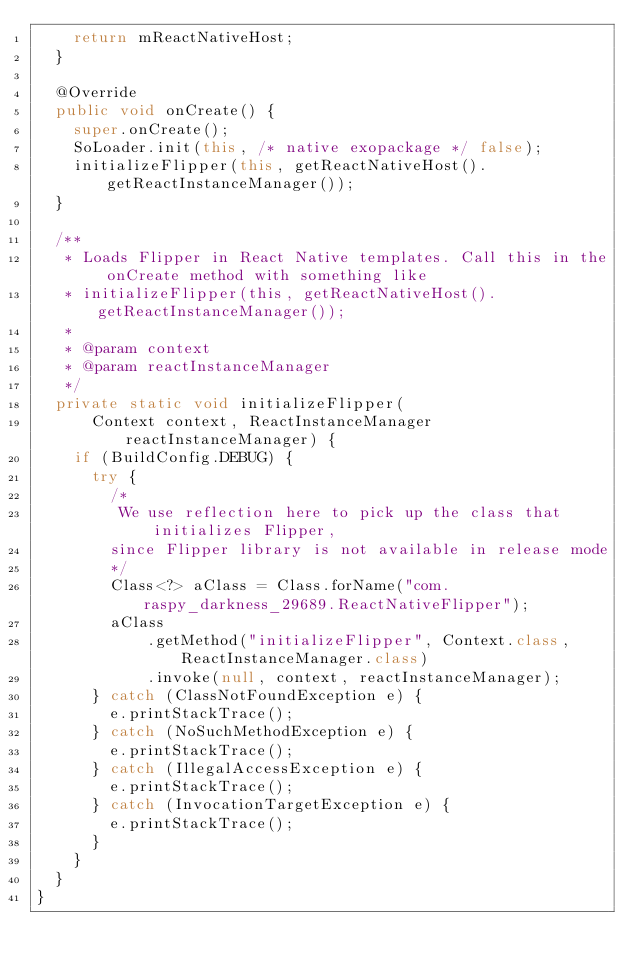<code> <loc_0><loc_0><loc_500><loc_500><_Java_>    return mReactNativeHost;
  }

  @Override
  public void onCreate() {
    super.onCreate();
    SoLoader.init(this, /* native exopackage */ false);
    initializeFlipper(this, getReactNativeHost().getReactInstanceManager());
  }

  /**
   * Loads Flipper in React Native templates. Call this in the onCreate method with something like
   * initializeFlipper(this, getReactNativeHost().getReactInstanceManager());
   *
   * @param context
   * @param reactInstanceManager
   */
  private static void initializeFlipper(
      Context context, ReactInstanceManager reactInstanceManager) {
    if (BuildConfig.DEBUG) {
      try {
        /*
         We use reflection here to pick up the class that initializes Flipper,
        since Flipper library is not available in release mode
        */
        Class<?> aClass = Class.forName("com.raspy_darkness_29689.ReactNativeFlipper");
        aClass
            .getMethod("initializeFlipper", Context.class, ReactInstanceManager.class)
            .invoke(null, context, reactInstanceManager);
      } catch (ClassNotFoundException e) {
        e.printStackTrace();
      } catch (NoSuchMethodException e) {
        e.printStackTrace();
      } catch (IllegalAccessException e) {
        e.printStackTrace();
      } catch (InvocationTargetException e) {
        e.printStackTrace();
      }
    }
  }
}
</code> 